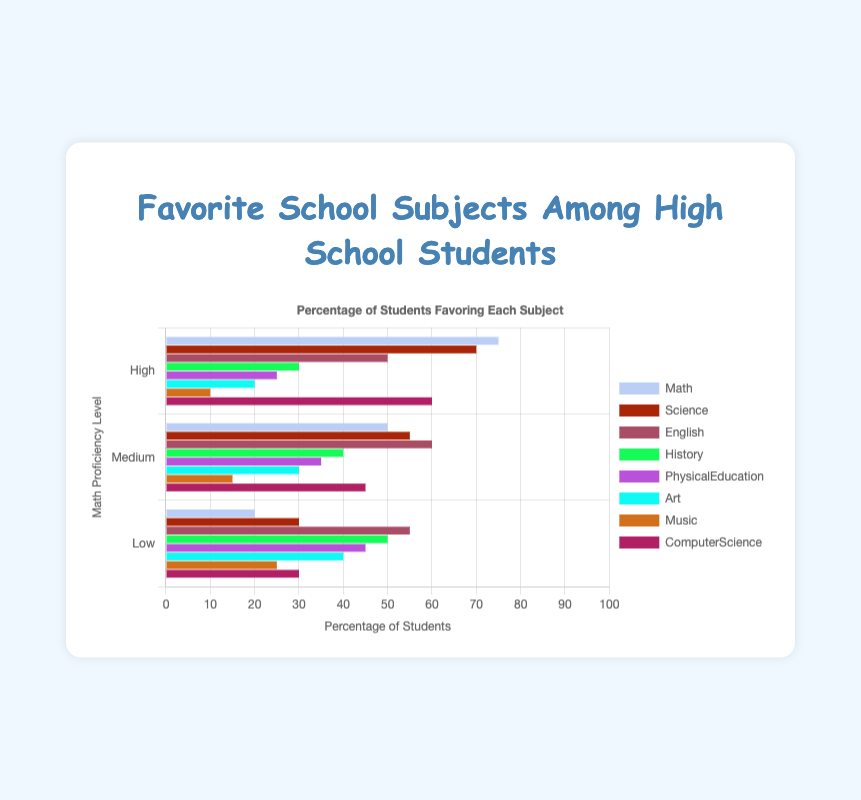Which subject is the most favored among students with high proficiency in math? The chart shows the percentage of students with different proficiency levels in math who favor each subject. For students with high proficiency, the highest bar indicates the most favored subject, which is "Math" at 75%.
Answer: Math What is the difference in the percentage of students favoring science between high and low proficiency groups? From the chart, the percentage of students favoring science is 70% for high proficiency and 30% for low proficiency. The difference is calculated as 70 - 30 = 40.
Answer: 40 Which subject has the closest percentage of favorability to math among students with low proficiency in math? For the low proficiency group, the favorability percentage of math is 20%. By comparing other subjects, the closest is "Music" at 25%, which is only 5% different.
Answer: Music Rank the favorability of English across proficiency levels from highest to lowest. For English, the percentages are: Medium (60%), Low (55%), and High (50%). Thus, the ranking from highest to lowest is Medium, Low, High.
Answer: Medium, Low, High Compare the favorability of art and music among medium proficiency students. Which is favored more and by how much? For students with medium proficiency, the favorability of art is 30% and for music, it is 15%. Art is favored more, and the difference is 30 - 15 = 15.
Answer: Art; 15 What is the average percentage of students favoring computer science across all proficiency levels? The percentages for computer science are High (60%), Medium (45%), and Low (30%). Summing them up, 60 + 45 + 30 = 135. Dividing by the number of groups: 135 / 3 = 45.
Answer: 45 Which subject has the least favorability among students with high proficiency in math, and what is the percentage? The subject with the smallest percentage bar for students with high proficiency is "Music," with a favorability of 10%.
Answer: Music; 10 By how much does the favorability of physical education differ between high and medium proficiency groups? The chart shows that for physical education, high proficiency students have a favorability of 25% and medium proficiency students have 35%. The difference is 35 - 25 = 10.
Answer: 10 How does the favorability of history compare between high and low proficiency groups? For history, high proficiency students have a favorability of 30% while low proficiency students have 50%. Low proficiency favor history more by 20%.
Answer: Low proficiency; 20 